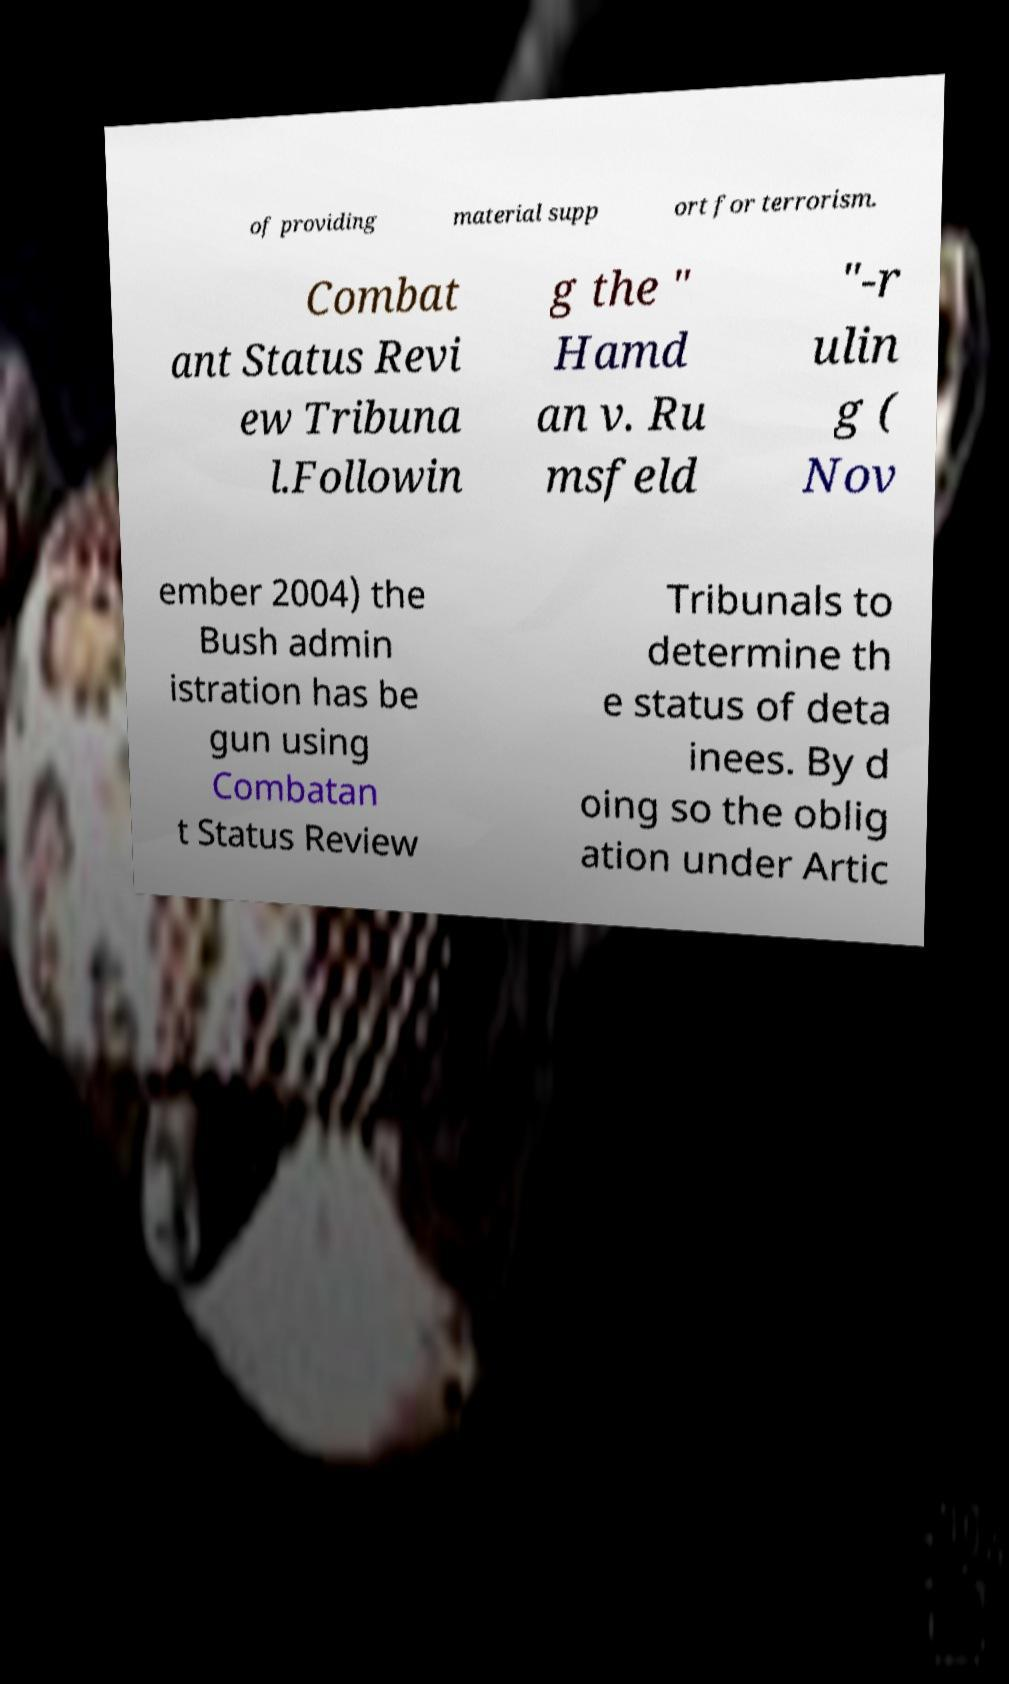Can you read and provide the text displayed in the image?This photo seems to have some interesting text. Can you extract and type it out for me? of providing material supp ort for terrorism. Combat ant Status Revi ew Tribuna l.Followin g the " Hamd an v. Ru msfeld "-r ulin g ( Nov ember 2004) the Bush admin istration has be gun using Combatan t Status Review Tribunals to determine th e status of deta inees. By d oing so the oblig ation under Artic 